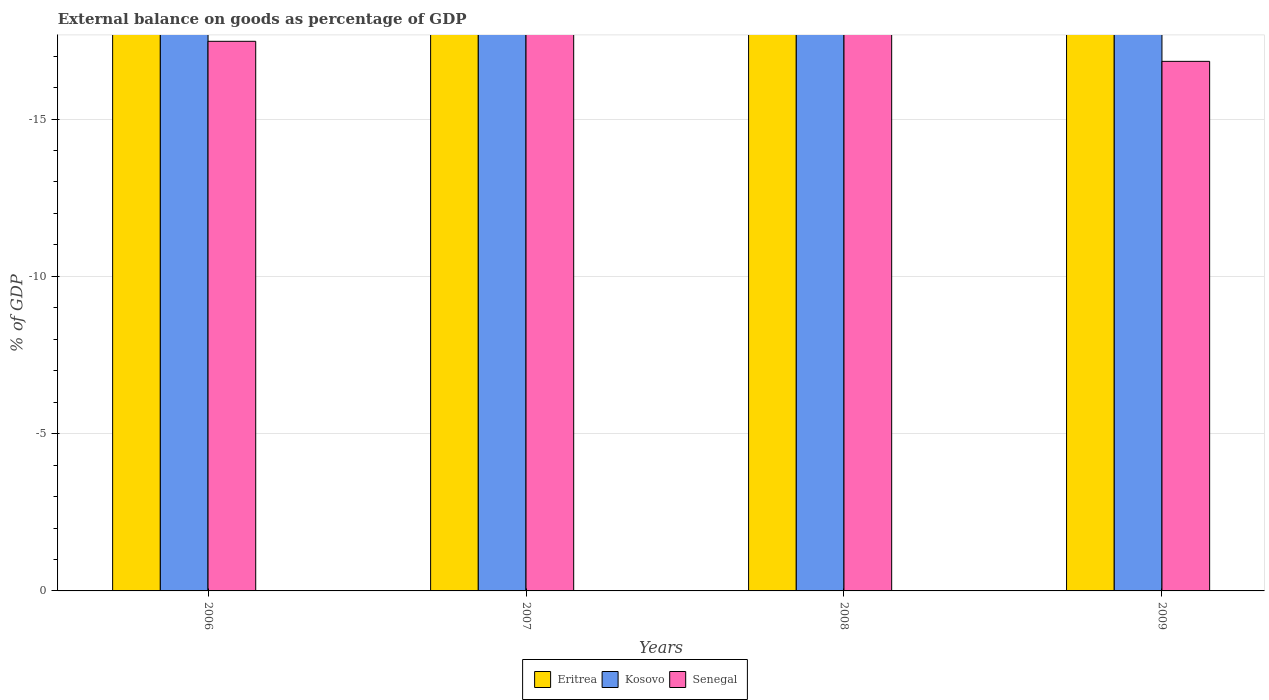How many bars are there on the 4th tick from the right?
Provide a succinct answer. 0. What is the label of the 3rd group of bars from the left?
Provide a succinct answer. 2008. What is the external balance on goods as percentage of GDP in Eritrea in 2006?
Your answer should be compact. 0. Across all years, what is the minimum external balance on goods as percentage of GDP in Senegal?
Provide a succinct answer. 0. In how many years, is the external balance on goods as percentage of GDP in Kosovo greater than the average external balance on goods as percentage of GDP in Kosovo taken over all years?
Offer a terse response. 0. How many bars are there?
Give a very brief answer. 0. Are all the bars in the graph horizontal?
Your answer should be very brief. No. What is the difference between two consecutive major ticks on the Y-axis?
Offer a terse response. 5. Are the values on the major ticks of Y-axis written in scientific E-notation?
Offer a terse response. No. Does the graph contain any zero values?
Offer a very short reply. Yes. Does the graph contain grids?
Your answer should be compact. Yes. Where does the legend appear in the graph?
Offer a very short reply. Bottom center. How are the legend labels stacked?
Provide a succinct answer. Horizontal. What is the title of the graph?
Your response must be concise. External balance on goods as percentage of GDP. What is the label or title of the Y-axis?
Offer a terse response. % of GDP. What is the % of GDP of Eritrea in 2006?
Offer a very short reply. 0. What is the % of GDP in Eritrea in 2008?
Your answer should be very brief. 0. What is the % of GDP of Senegal in 2008?
Your answer should be compact. 0. What is the % of GDP in Eritrea in 2009?
Your response must be concise. 0. What is the % of GDP of Kosovo in 2009?
Give a very brief answer. 0. What is the % of GDP of Senegal in 2009?
Provide a short and direct response. 0. What is the total % of GDP of Eritrea in the graph?
Offer a terse response. 0. What is the total % of GDP in Kosovo in the graph?
Your answer should be compact. 0. What is the average % of GDP in Senegal per year?
Your answer should be compact. 0. 